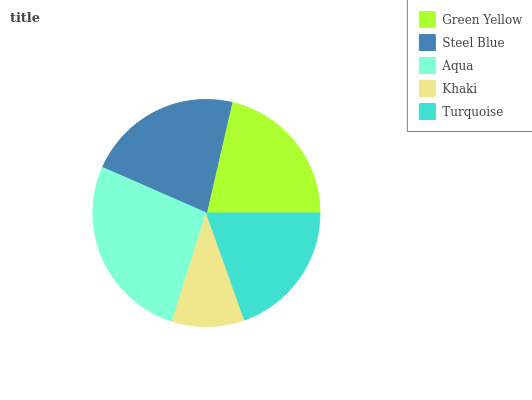Is Khaki the minimum?
Answer yes or no. Yes. Is Aqua the maximum?
Answer yes or no. Yes. Is Steel Blue the minimum?
Answer yes or no. No. Is Steel Blue the maximum?
Answer yes or no. No. Is Steel Blue greater than Green Yellow?
Answer yes or no. Yes. Is Green Yellow less than Steel Blue?
Answer yes or no. Yes. Is Green Yellow greater than Steel Blue?
Answer yes or no. No. Is Steel Blue less than Green Yellow?
Answer yes or no. No. Is Green Yellow the high median?
Answer yes or no. Yes. Is Green Yellow the low median?
Answer yes or no. Yes. Is Aqua the high median?
Answer yes or no. No. Is Khaki the low median?
Answer yes or no. No. 